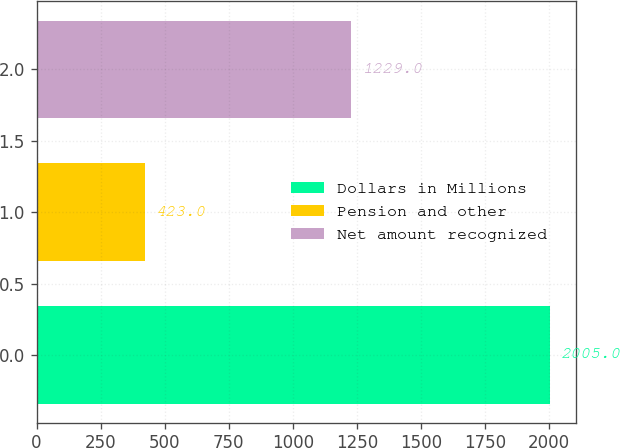Convert chart. <chart><loc_0><loc_0><loc_500><loc_500><bar_chart><fcel>Dollars in Millions<fcel>Pension and other<fcel>Net amount recognized<nl><fcel>2005<fcel>423<fcel>1229<nl></chart> 